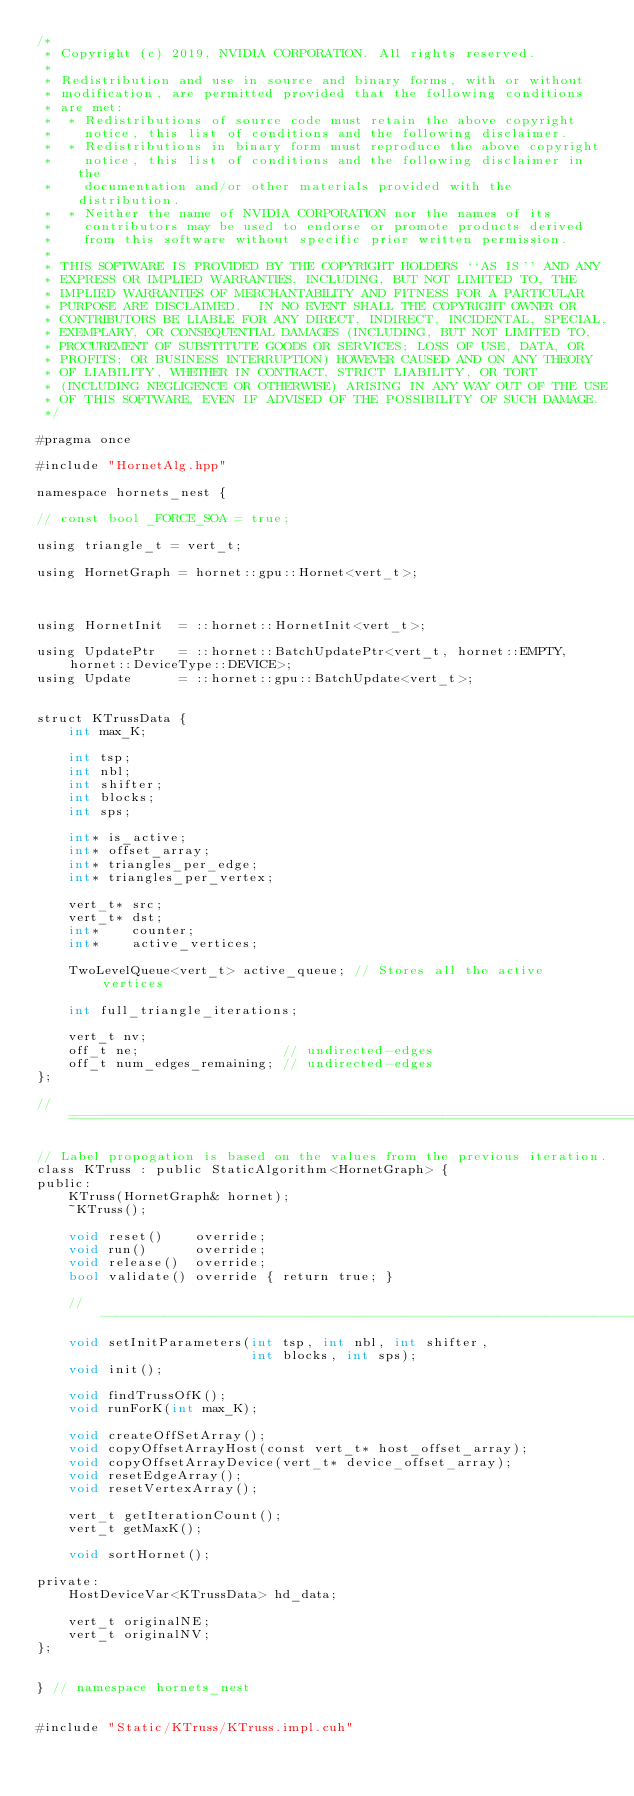Convert code to text. <code><loc_0><loc_0><loc_500><loc_500><_Cuda_>/*
 * Copyright (c) 2019, NVIDIA CORPORATION. All rights reserved.
 *
 * Redistribution and use in source and binary forms, with or without
 * modification, are permitted provided that the following conditions
 * are met:
 *  * Redistributions of source code must retain the above copyright
 *    notice, this list of conditions and the following disclaimer.
 *  * Redistributions in binary form must reproduce the above copyright
 *    notice, this list of conditions and the following disclaimer in the
 *    documentation and/or other materials provided with the distribution.
 *  * Neither the name of NVIDIA CORPORATION nor the names of its
 *    contributors may be used to endorse or promote products derived
 *    from this software without specific prior written permission.
 *
 * THIS SOFTWARE IS PROVIDED BY THE COPYRIGHT HOLDERS ``AS IS'' AND ANY
 * EXPRESS OR IMPLIED WARRANTIES, INCLUDING, BUT NOT LIMITED TO, THE
 * IMPLIED WARRANTIES OF MERCHANTABILITY AND FITNESS FOR A PARTICULAR
 * PURPOSE ARE DISCLAIMED.  IN NO EVENT SHALL THE COPYRIGHT OWNER OR
 * CONTRIBUTORS BE LIABLE FOR ANY DIRECT, INDIRECT, INCIDENTAL, SPECIAL,
 * EXEMPLARY, OR CONSEQUENTIAL DAMAGES (INCLUDING, BUT NOT LIMITED TO,
 * PROCUREMENT OF SUBSTITUTE GOODS OR SERVICES; LOSS OF USE, DATA, OR
 * PROFITS; OR BUSINESS INTERRUPTION) HOWEVER CAUSED AND ON ANY THEORY
 * OF LIABILITY, WHETHER IN CONTRACT, STRICT LIABILITY, OR TORT
 * (INCLUDING NEGLIGENCE OR OTHERWISE) ARISING IN ANY WAY OUT OF THE USE
 * OF THIS SOFTWARE, EVEN IF ADVISED OF THE POSSIBILITY OF SUCH DAMAGE.
 */

#pragma once

#include "HornetAlg.hpp"

namespace hornets_nest {

// const bool _FORCE_SOA = true;

using triangle_t = vert_t;

using HornetGraph = hornet::gpu::Hornet<vert_t>;



using HornetInit  = ::hornet::HornetInit<vert_t>;

using UpdatePtr   = ::hornet::BatchUpdatePtr<vert_t, hornet::EMPTY, hornet::DeviceType::DEVICE>;
using Update      = ::hornet::gpu::BatchUpdate<vert_t>;


struct KTrussData {
    int max_K;

    int tsp;
    int nbl;
    int shifter;
    int blocks;
    int sps;

    int* is_active;
    int* offset_array;
    int* triangles_per_edge;
    int* triangles_per_vertex;

    vert_t* src;
    vert_t* dst;
    int*    counter;
    int*    active_vertices;

    TwoLevelQueue<vert_t> active_queue; // Stores all the active vertices

    int full_triangle_iterations;

    vert_t nv;
    off_t ne;                  // undirected-edges
    off_t num_edges_remaining; // undirected-edges
};

//==============================================================================

// Label propogation is based on the values from the previous iteration.
class KTruss : public StaticAlgorithm<HornetGraph> {
public:
    KTruss(HornetGraph& hornet);
    ~KTruss();

    void reset()    override;
    void run()      override;
    void release()  override;
    bool validate() override { return true; }

    //--------------------------------------------------------------------------
    void setInitParameters(int tsp, int nbl, int shifter,
                           int blocks, int sps);
    void init();

    void findTrussOfK();
    void runForK(int max_K);

    void createOffSetArray();
    void copyOffsetArrayHost(const vert_t* host_offset_array);
    void copyOffsetArrayDevice(vert_t* device_offset_array);
    void resetEdgeArray();
    void resetVertexArray();

    vert_t getIterationCount();
    vert_t getMaxK();

    void sortHornet();

private:
    HostDeviceVar<KTrussData> hd_data;

    vert_t originalNE;
    vert_t originalNV;
};


} // namespace hornets_nest


#include "Static/KTruss/KTruss.impl.cuh"</code> 